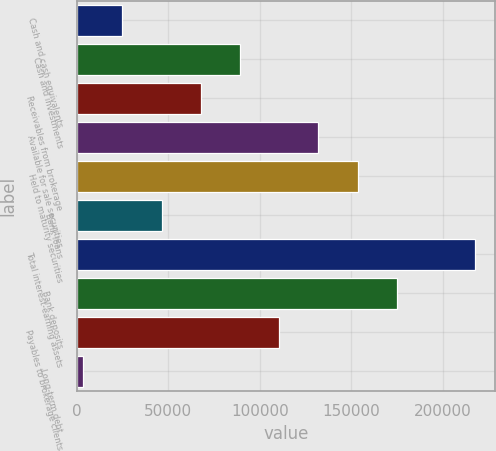<chart> <loc_0><loc_0><loc_500><loc_500><bar_chart><fcel>Cash and cash equivalents<fcel>Cash and investments<fcel>Receivables from brokerage<fcel>Available for sale securities<fcel>Held to maturity securities<fcel>Bank loans<fcel>Total interest-earning assets<fcel>Bank deposits<fcel>Payables to brokerage clients<fcel>Long-term debt<nl><fcel>24859.2<fcel>89143.8<fcel>67715.6<fcel>132000<fcel>153428<fcel>46287.4<fcel>217763<fcel>174857<fcel>110572<fcel>3431<nl></chart> 